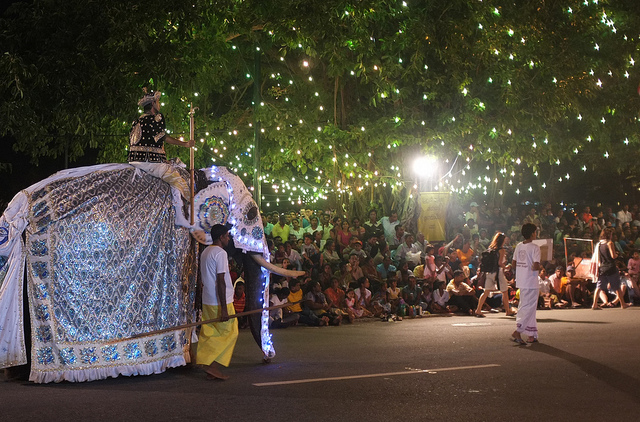<image>What state flag is similar to an image in this picture? I don't know what state flag is similar to an image in this picture. It could be Tennessee, Nevada, Kansas, USA, Arizona, Louisiana, or none. Where is this? I am not sure where this is. It can be in India or a parade scene. What state flag is similar to an image in this picture? It is ambiguous which state flag is similar to an image in this picture. Where is this? This location is unknown. It can be in India, Cambodia or at a parade. 